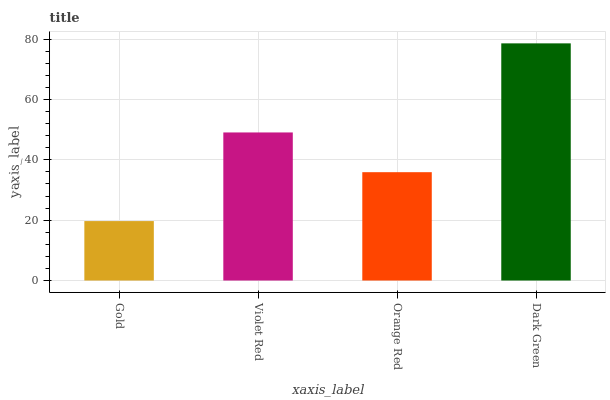Is Gold the minimum?
Answer yes or no. Yes. Is Dark Green the maximum?
Answer yes or no. Yes. Is Violet Red the minimum?
Answer yes or no. No. Is Violet Red the maximum?
Answer yes or no. No. Is Violet Red greater than Gold?
Answer yes or no. Yes. Is Gold less than Violet Red?
Answer yes or no. Yes. Is Gold greater than Violet Red?
Answer yes or no. No. Is Violet Red less than Gold?
Answer yes or no. No. Is Violet Red the high median?
Answer yes or no. Yes. Is Orange Red the low median?
Answer yes or no. Yes. Is Orange Red the high median?
Answer yes or no. No. Is Violet Red the low median?
Answer yes or no. No. 